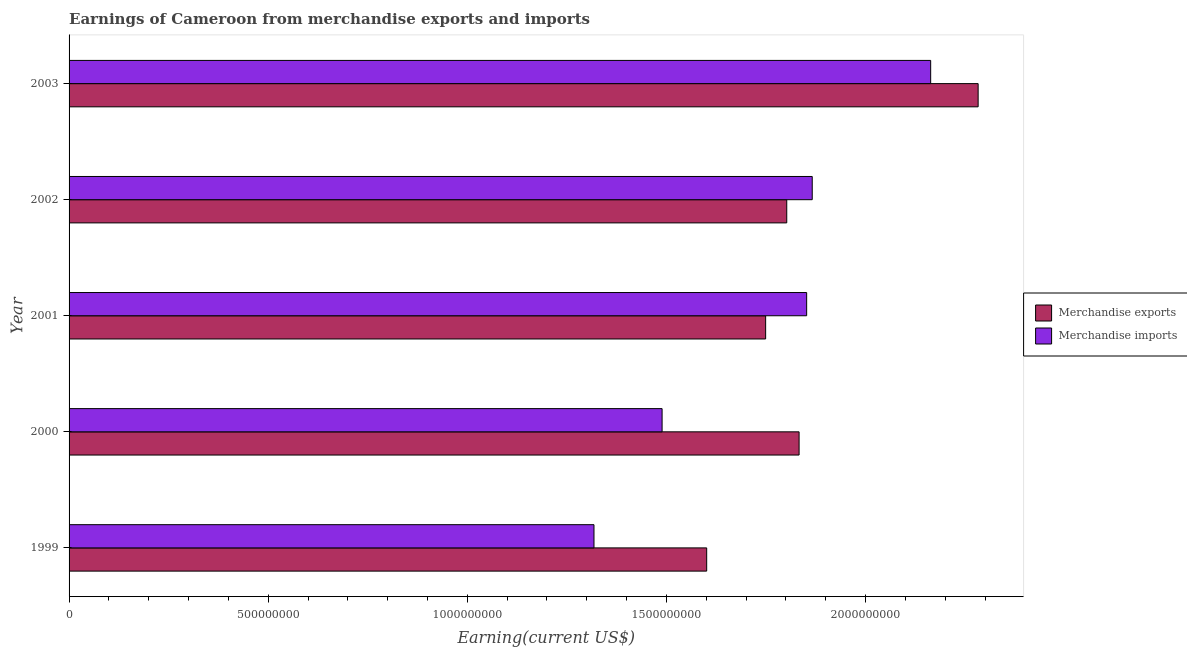How many different coloured bars are there?
Keep it short and to the point. 2. What is the label of the 4th group of bars from the top?
Keep it short and to the point. 2000. What is the earnings from merchandise exports in 2002?
Make the answer very short. 1.80e+09. Across all years, what is the maximum earnings from merchandise exports?
Offer a very short reply. 2.28e+09. Across all years, what is the minimum earnings from merchandise exports?
Your response must be concise. 1.60e+09. In which year was the earnings from merchandise imports maximum?
Your response must be concise. 2003. What is the total earnings from merchandise imports in the graph?
Provide a short and direct response. 8.69e+09. What is the difference between the earnings from merchandise imports in 1999 and that in 2001?
Make the answer very short. -5.34e+08. What is the difference between the earnings from merchandise exports in 2002 and the earnings from merchandise imports in 2000?
Your answer should be compact. 3.13e+08. What is the average earnings from merchandise exports per year?
Your answer should be compact. 1.85e+09. In the year 2003, what is the difference between the earnings from merchandise exports and earnings from merchandise imports?
Make the answer very short. 1.19e+08. What is the ratio of the earnings from merchandise exports in 2002 to that in 2003?
Your response must be concise. 0.79. What is the difference between the highest and the second highest earnings from merchandise exports?
Your answer should be compact. 4.50e+08. What is the difference between the highest and the lowest earnings from merchandise exports?
Provide a short and direct response. 6.82e+08. In how many years, is the earnings from merchandise exports greater than the average earnings from merchandise exports taken over all years?
Offer a very short reply. 1. Is the sum of the earnings from merchandise exports in 1999 and 2003 greater than the maximum earnings from merchandise imports across all years?
Offer a very short reply. Yes. What does the 2nd bar from the bottom in 2001 represents?
Ensure brevity in your answer.  Merchandise imports. Are all the bars in the graph horizontal?
Make the answer very short. Yes. How many years are there in the graph?
Offer a terse response. 5. What is the difference between two consecutive major ticks on the X-axis?
Your answer should be compact. 5.00e+08. Are the values on the major ticks of X-axis written in scientific E-notation?
Your response must be concise. No. Does the graph contain grids?
Give a very brief answer. No. How are the legend labels stacked?
Offer a very short reply. Vertical. What is the title of the graph?
Offer a terse response. Earnings of Cameroon from merchandise exports and imports. Does "Ages 15-24" appear as one of the legend labels in the graph?
Ensure brevity in your answer.  No. What is the label or title of the X-axis?
Your answer should be very brief. Earning(current US$). What is the Earning(current US$) of Merchandise exports in 1999?
Offer a very short reply. 1.60e+09. What is the Earning(current US$) of Merchandise imports in 1999?
Offer a terse response. 1.32e+09. What is the Earning(current US$) in Merchandise exports in 2000?
Your response must be concise. 1.83e+09. What is the Earning(current US$) of Merchandise imports in 2000?
Ensure brevity in your answer.  1.49e+09. What is the Earning(current US$) of Merchandise exports in 2001?
Offer a terse response. 1.75e+09. What is the Earning(current US$) of Merchandise imports in 2001?
Your response must be concise. 1.85e+09. What is the Earning(current US$) of Merchandise exports in 2002?
Ensure brevity in your answer.  1.80e+09. What is the Earning(current US$) in Merchandise imports in 2002?
Your response must be concise. 1.87e+09. What is the Earning(current US$) of Merchandise exports in 2003?
Your response must be concise. 2.28e+09. What is the Earning(current US$) of Merchandise imports in 2003?
Keep it short and to the point. 2.16e+09. Across all years, what is the maximum Earning(current US$) of Merchandise exports?
Offer a very short reply. 2.28e+09. Across all years, what is the maximum Earning(current US$) of Merchandise imports?
Make the answer very short. 2.16e+09. Across all years, what is the minimum Earning(current US$) of Merchandise exports?
Provide a short and direct response. 1.60e+09. Across all years, what is the minimum Earning(current US$) of Merchandise imports?
Your answer should be compact. 1.32e+09. What is the total Earning(current US$) in Merchandise exports in the graph?
Your answer should be compact. 9.27e+09. What is the total Earning(current US$) in Merchandise imports in the graph?
Offer a very short reply. 8.69e+09. What is the difference between the Earning(current US$) of Merchandise exports in 1999 and that in 2000?
Provide a succinct answer. -2.32e+08. What is the difference between the Earning(current US$) in Merchandise imports in 1999 and that in 2000?
Offer a terse response. -1.71e+08. What is the difference between the Earning(current US$) of Merchandise exports in 1999 and that in 2001?
Keep it short and to the point. -1.48e+08. What is the difference between the Earning(current US$) in Merchandise imports in 1999 and that in 2001?
Offer a very short reply. -5.34e+08. What is the difference between the Earning(current US$) of Merchandise exports in 1999 and that in 2002?
Offer a very short reply. -2.01e+08. What is the difference between the Earning(current US$) in Merchandise imports in 1999 and that in 2002?
Offer a terse response. -5.48e+08. What is the difference between the Earning(current US$) in Merchandise exports in 1999 and that in 2003?
Ensure brevity in your answer.  -6.82e+08. What is the difference between the Earning(current US$) in Merchandise imports in 1999 and that in 2003?
Your answer should be compact. -8.45e+08. What is the difference between the Earning(current US$) of Merchandise exports in 2000 and that in 2001?
Ensure brevity in your answer.  8.40e+07. What is the difference between the Earning(current US$) of Merchandise imports in 2000 and that in 2001?
Your response must be concise. -3.63e+08. What is the difference between the Earning(current US$) in Merchandise exports in 2000 and that in 2002?
Ensure brevity in your answer.  3.10e+07. What is the difference between the Earning(current US$) in Merchandise imports in 2000 and that in 2002?
Give a very brief answer. -3.77e+08. What is the difference between the Earning(current US$) of Merchandise exports in 2000 and that in 2003?
Your response must be concise. -4.50e+08. What is the difference between the Earning(current US$) of Merchandise imports in 2000 and that in 2003?
Offer a terse response. -6.74e+08. What is the difference between the Earning(current US$) of Merchandise exports in 2001 and that in 2002?
Offer a very short reply. -5.30e+07. What is the difference between the Earning(current US$) of Merchandise imports in 2001 and that in 2002?
Offer a terse response. -1.40e+07. What is the difference between the Earning(current US$) in Merchandise exports in 2001 and that in 2003?
Your answer should be compact. -5.34e+08. What is the difference between the Earning(current US$) in Merchandise imports in 2001 and that in 2003?
Your answer should be very brief. -3.11e+08. What is the difference between the Earning(current US$) in Merchandise exports in 2002 and that in 2003?
Your answer should be compact. -4.81e+08. What is the difference between the Earning(current US$) in Merchandise imports in 2002 and that in 2003?
Provide a succinct answer. -2.97e+08. What is the difference between the Earning(current US$) in Merchandise exports in 1999 and the Earning(current US$) in Merchandise imports in 2000?
Provide a succinct answer. 1.12e+08. What is the difference between the Earning(current US$) of Merchandise exports in 1999 and the Earning(current US$) of Merchandise imports in 2001?
Provide a succinct answer. -2.51e+08. What is the difference between the Earning(current US$) in Merchandise exports in 1999 and the Earning(current US$) in Merchandise imports in 2002?
Ensure brevity in your answer.  -2.65e+08. What is the difference between the Earning(current US$) of Merchandise exports in 1999 and the Earning(current US$) of Merchandise imports in 2003?
Provide a short and direct response. -5.62e+08. What is the difference between the Earning(current US$) in Merchandise exports in 2000 and the Earning(current US$) in Merchandise imports in 2001?
Give a very brief answer. -1.90e+07. What is the difference between the Earning(current US$) in Merchandise exports in 2000 and the Earning(current US$) in Merchandise imports in 2002?
Provide a short and direct response. -3.30e+07. What is the difference between the Earning(current US$) in Merchandise exports in 2000 and the Earning(current US$) in Merchandise imports in 2003?
Give a very brief answer. -3.30e+08. What is the difference between the Earning(current US$) of Merchandise exports in 2001 and the Earning(current US$) of Merchandise imports in 2002?
Make the answer very short. -1.17e+08. What is the difference between the Earning(current US$) in Merchandise exports in 2001 and the Earning(current US$) in Merchandise imports in 2003?
Make the answer very short. -4.14e+08. What is the difference between the Earning(current US$) in Merchandise exports in 2002 and the Earning(current US$) in Merchandise imports in 2003?
Your answer should be very brief. -3.61e+08. What is the average Earning(current US$) of Merchandise exports per year?
Provide a short and direct response. 1.85e+09. What is the average Earning(current US$) in Merchandise imports per year?
Your answer should be very brief. 1.74e+09. In the year 1999, what is the difference between the Earning(current US$) of Merchandise exports and Earning(current US$) of Merchandise imports?
Give a very brief answer. 2.83e+08. In the year 2000, what is the difference between the Earning(current US$) of Merchandise exports and Earning(current US$) of Merchandise imports?
Make the answer very short. 3.44e+08. In the year 2001, what is the difference between the Earning(current US$) of Merchandise exports and Earning(current US$) of Merchandise imports?
Give a very brief answer. -1.03e+08. In the year 2002, what is the difference between the Earning(current US$) in Merchandise exports and Earning(current US$) in Merchandise imports?
Make the answer very short. -6.40e+07. In the year 2003, what is the difference between the Earning(current US$) in Merchandise exports and Earning(current US$) in Merchandise imports?
Give a very brief answer. 1.19e+08. What is the ratio of the Earning(current US$) in Merchandise exports in 1999 to that in 2000?
Provide a succinct answer. 0.87. What is the ratio of the Earning(current US$) of Merchandise imports in 1999 to that in 2000?
Offer a terse response. 0.89. What is the ratio of the Earning(current US$) of Merchandise exports in 1999 to that in 2001?
Your answer should be very brief. 0.92. What is the ratio of the Earning(current US$) of Merchandise imports in 1999 to that in 2001?
Keep it short and to the point. 0.71. What is the ratio of the Earning(current US$) in Merchandise exports in 1999 to that in 2002?
Ensure brevity in your answer.  0.89. What is the ratio of the Earning(current US$) in Merchandise imports in 1999 to that in 2002?
Provide a short and direct response. 0.71. What is the ratio of the Earning(current US$) of Merchandise exports in 1999 to that in 2003?
Your answer should be compact. 0.7. What is the ratio of the Earning(current US$) of Merchandise imports in 1999 to that in 2003?
Your answer should be very brief. 0.61. What is the ratio of the Earning(current US$) of Merchandise exports in 2000 to that in 2001?
Ensure brevity in your answer.  1.05. What is the ratio of the Earning(current US$) in Merchandise imports in 2000 to that in 2001?
Provide a short and direct response. 0.8. What is the ratio of the Earning(current US$) in Merchandise exports in 2000 to that in 2002?
Make the answer very short. 1.02. What is the ratio of the Earning(current US$) in Merchandise imports in 2000 to that in 2002?
Your answer should be very brief. 0.8. What is the ratio of the Earning(current US$) of Merchandise exports in 2000 to that in 2003?
Provide a short and direct response. 0.8. What is the ratio of the Earning(current US$) of Merchandise imports in 2000 to that in 2003?
Offer a very short reply. 0.69. What is the ratio of the Earning(current US$) in Merchandise exports in 2001 to that in 2002?
Make the answer very short. 0.97. What is the ratio of the Earning(current US$) of Merchandise imports in 2001 to that in 2002?
Your answer should be very brief. 0.99. What is the ratio of the Earning(current US$) in Merchandise exports in 2001 to that in 2003?
Provide a succinct answer. 0.77. What is the ratio of the Earning(current US$) of Merchandise imports in 2001 to that in 2003?
Offer a very short reply. 0.86. What is the ratio of the Earning(current US$) in Merchandise exports in 2002 to that in 2003?
Your response must be concise. 0.79. What is the ratio of the Earning(current US$) in Merchandise imports in 2002 to that in 2003?
Keep it short and to the point. 0.86. What is the difference between the highest and the second highest Earning(current US$) in Merchandise exports?
Offer a very short reply. 4.50e+08. What is the difference between the highest and the second highest Earning(current US$) of Merchandise imports?
Provide a short and direct response. 2.97e+08. What is the difference between the highest and the lowest Earning(current US$) in Merchandise exports?
Ensure brevity in your answer.  6.82e+08. What is the difference between the highest and the lowest Earning(current US$) in Merchandise imports?
Ensure brevity in your answer.  8.45e+08. 